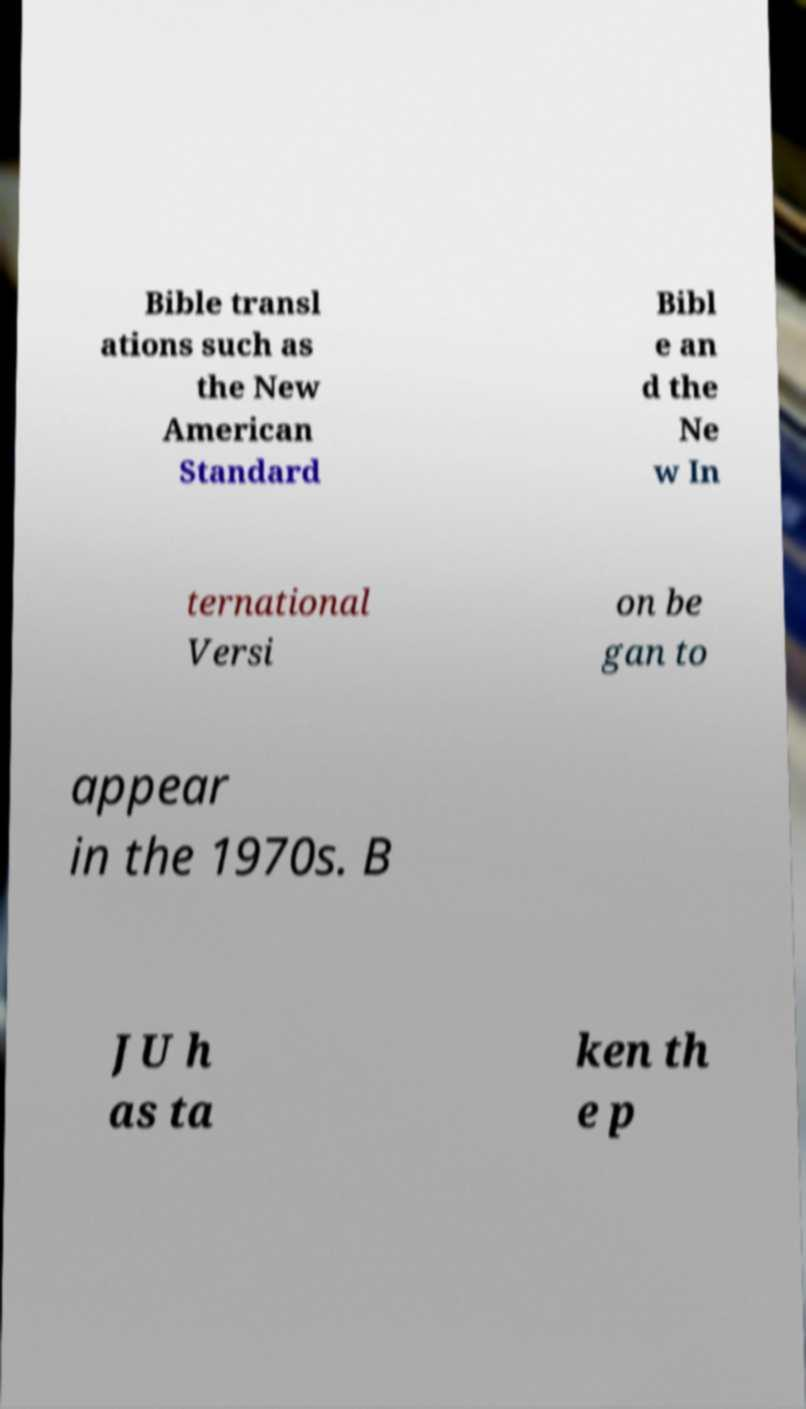Could you assist in decoding the text presented in this image and type it out clearly? Bible transl ations such as the New American Standard Bibl e an d the Ne w In ternational Versi on be gan to appear in the 1970s. B JU h as ta ken th e p 